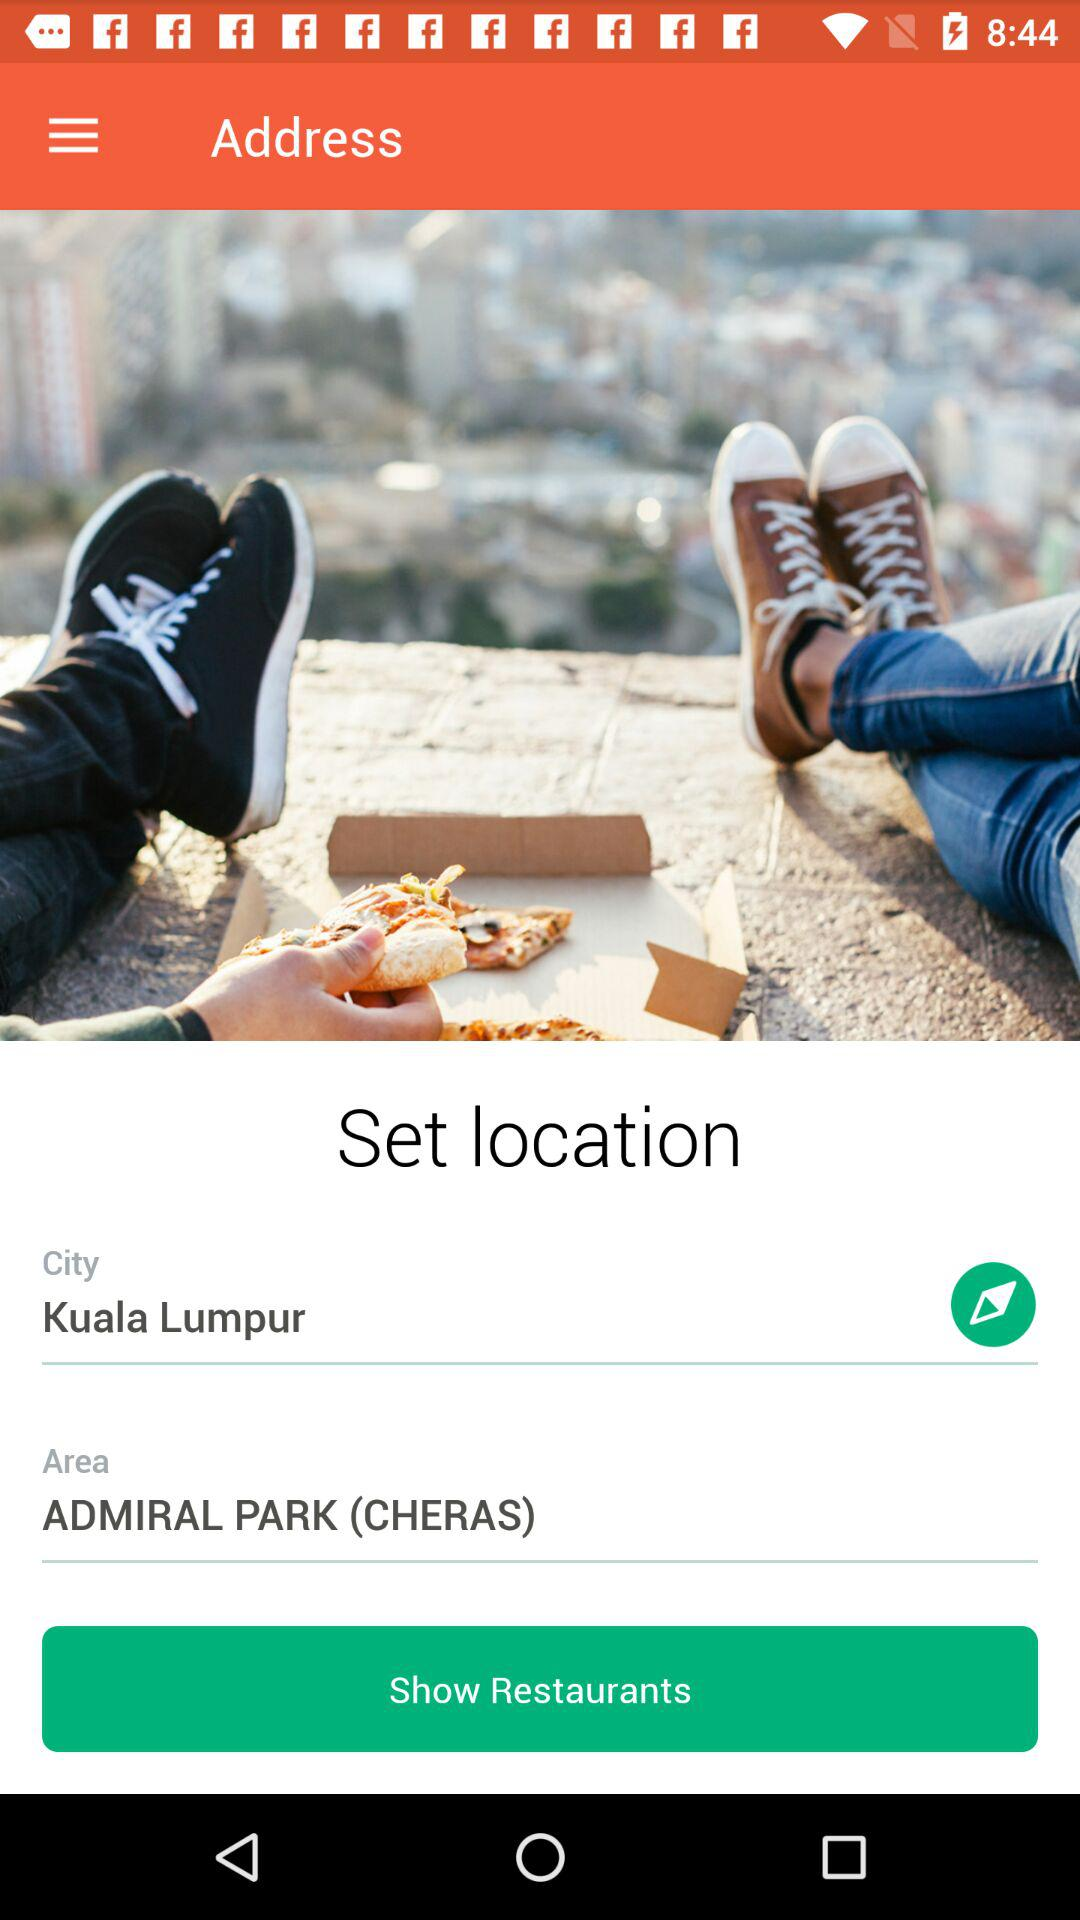Which area is selected? The selected area is Admiral Park (Cheras). 